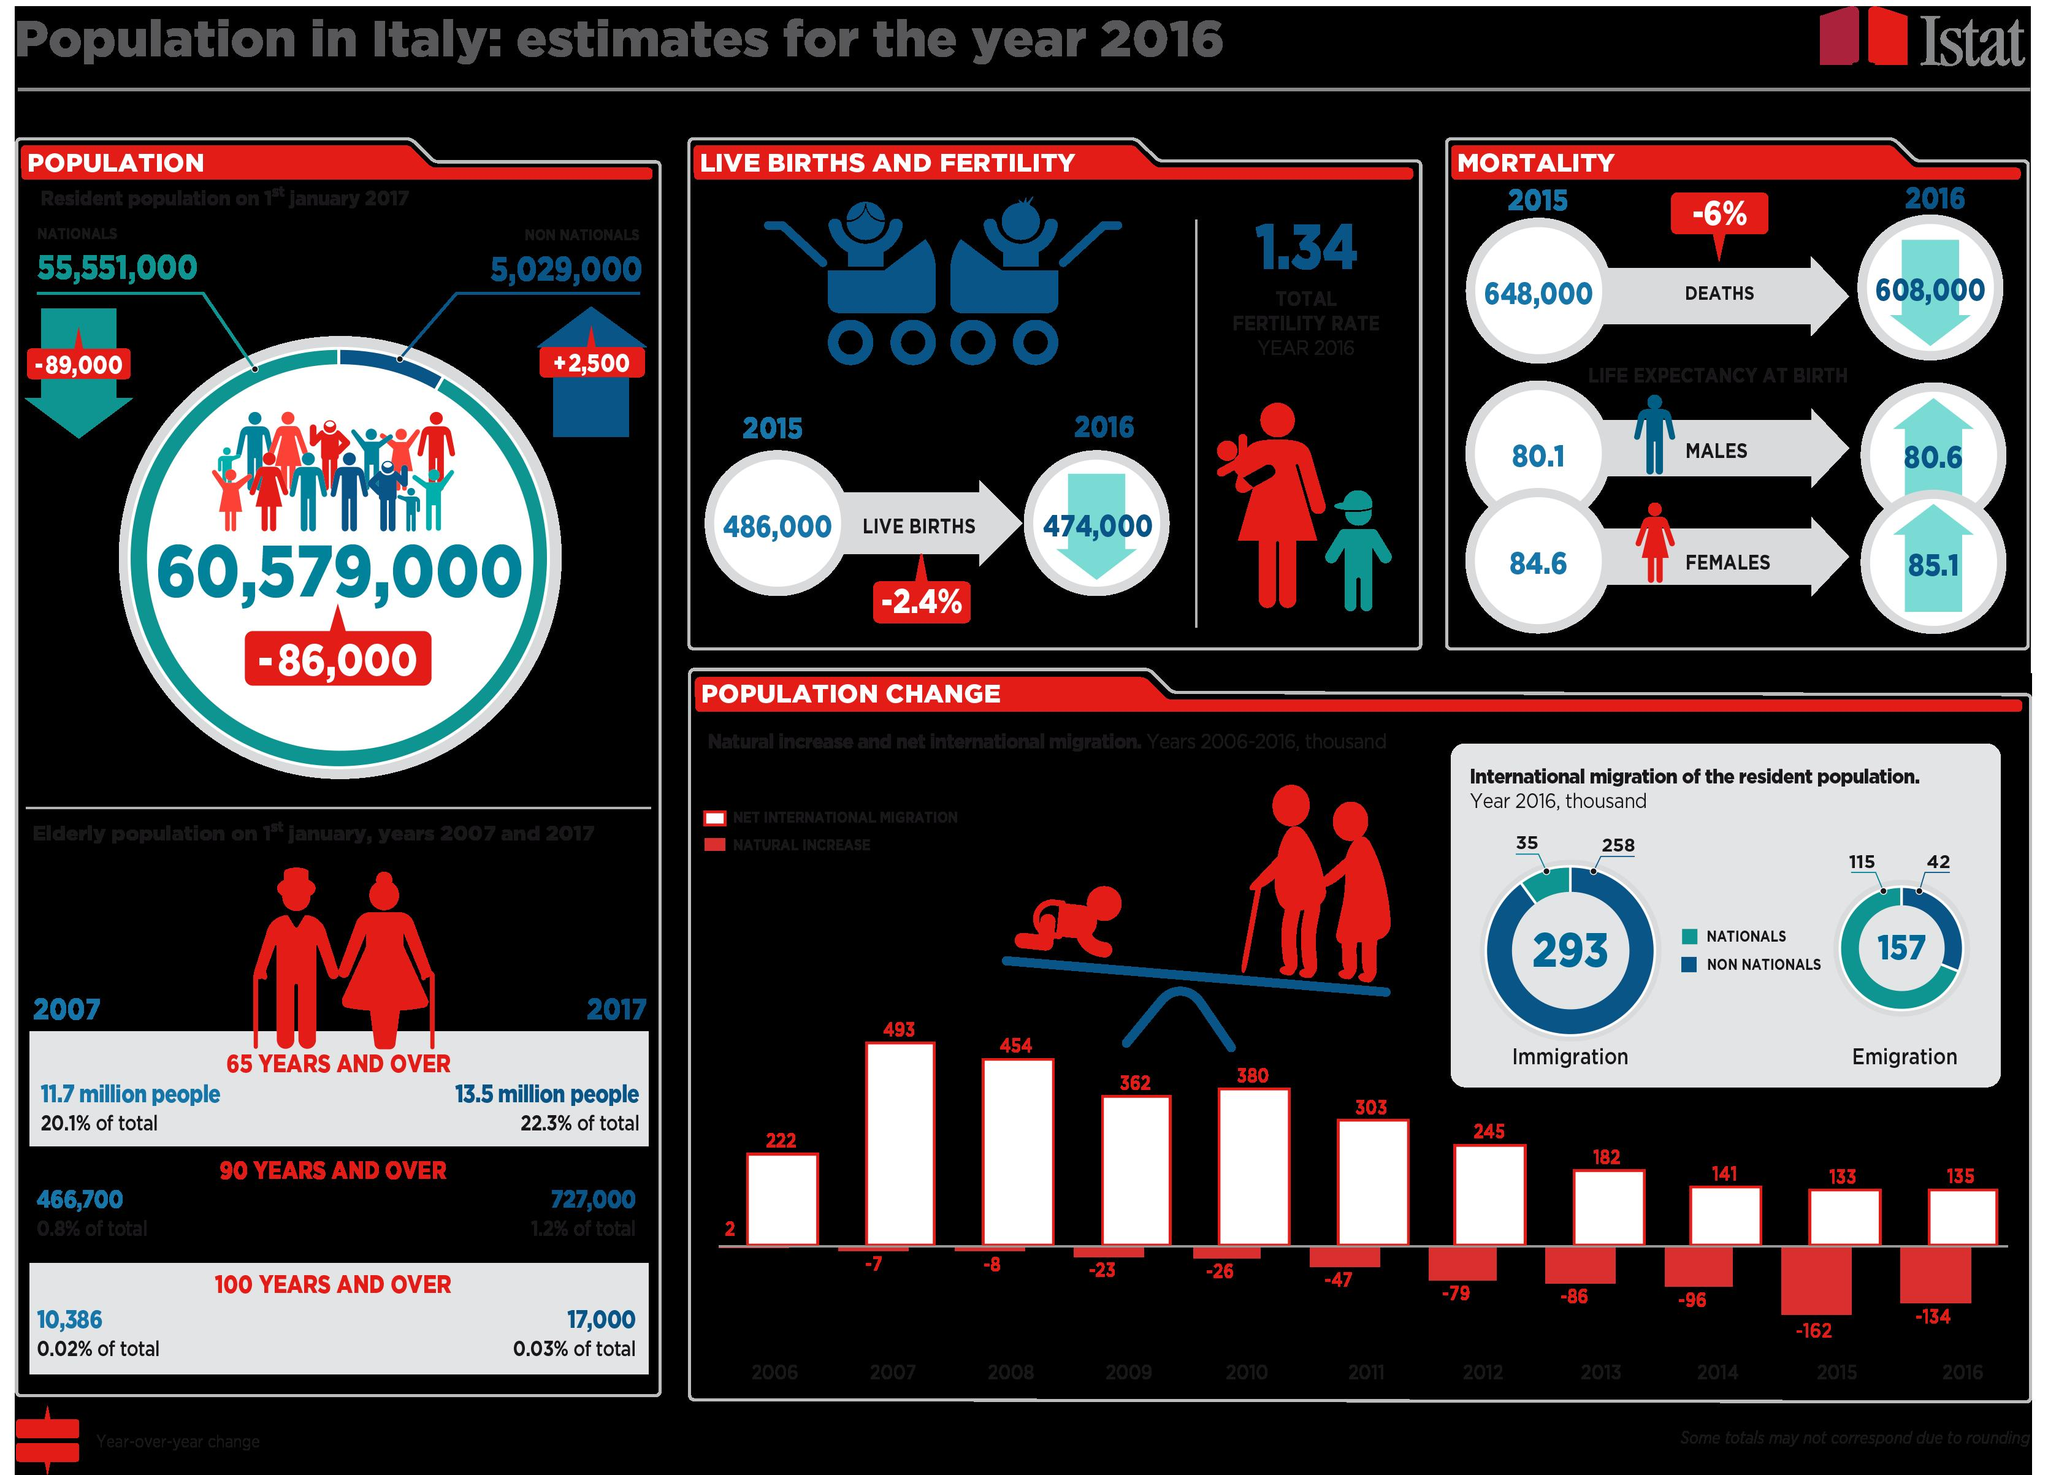Outline some significant characteristics in this image. The difference between the immigration of non-nationals and nationals lies in the fact that non-nationals are individuals who are not citizens of the country and must obtain a visa or other documentation to enter or stay in the country, while nationals are individuals who are citizens of the country and do not require a visa or other documentation to enter or stay in the country. The difference between the emigration of nationals and non-nationals is 73.. 